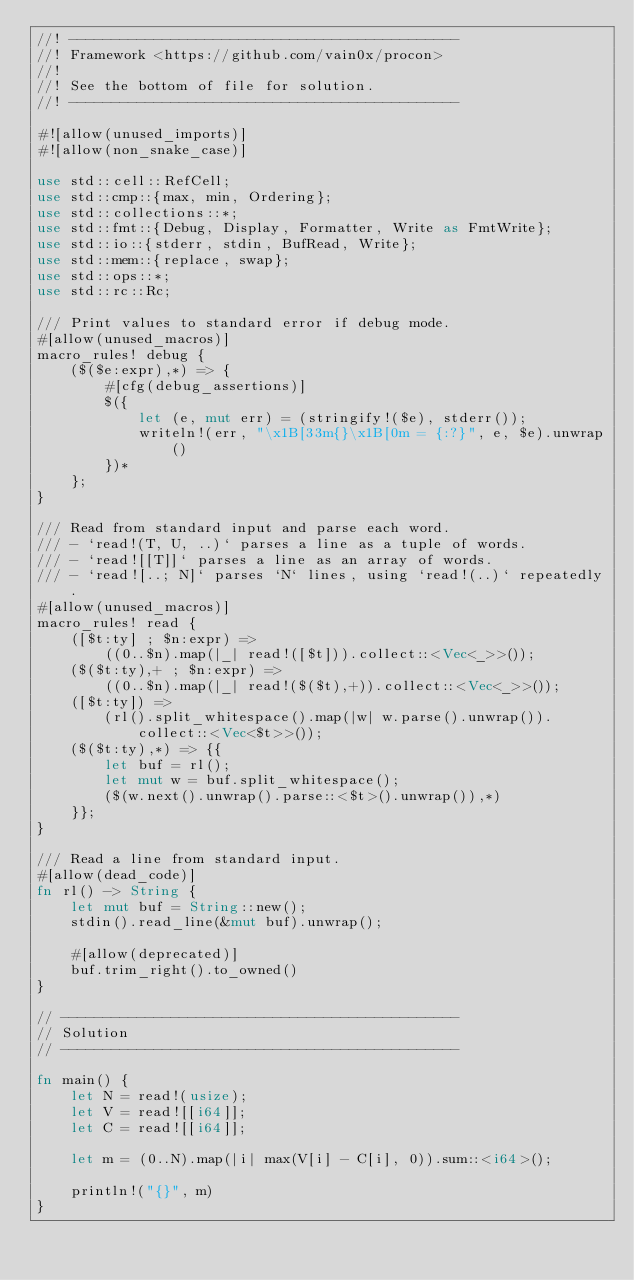Convert code to text. <code><loc_0><loc_0><loc_500><loc_500><_Rust_>//! ----------------------------------------------
//! Framework <https://github.com/vain0x/procon>
//!
//! See the bottom of file for solution.
//! ----------------------------------------------

#![allow(unused_imports)]
#![allow(non_snake_case)]

use std::cell::RefCell;
use std::cmp::{max, min, Ordering};
use std::collections::*;
use std::fmt::{Debug, Display, Formatter, Write as FmtWrite};
use std::io::{stderr, stdin, BufRead, Write};
use std::mem::{replace, swap};
use std::ops::*;
use std::rc::Rc;

/// Print values to standard error if debug mode.
#[allow(unused_macros)]
macro_rules! debug {
    ($($e:expr),*) => {
        #[cfg(debug_assertions)]
        $({
            let (e, mut err) = (stringify!($e), stderr());
            writeln!(err, "\x1B[33m{}\x1B[0m = {:?}", e, $e).unwrap()
        })*
    };
}

/// Read from standard input and parse each word.
/// - `read!(T, U, ..)` parses a line as a tuple of words.
/// - `read![[T]]` parses a line as an array of words.
/// - `read![..; N]` parses `N` lines, using `read!(..)` repeatedly.
#[allow(unused_macros)]
macro_rules! read {
    ([$t:ty] ; $n:expr) =>
        ((0..$n).map(|_| read!([$t])).collect::<Vec<_>>());
    ($($t:ty),+ ; $n:expr) =>
        ((0..$n).map(|_| read!($($t),+)).collect::<Vec<_>>());
    ([$t:ty]) =>
        (rl().split_whitespace().map(|w| w.parse().unwrap()).collect::<Vec<$t>>());
    ($($t:ty),*) => {{
        let buf = rl();
        let mut w = buf.split_whitespace();
        ($(w.next().unwrap().parse::<$t>().unwrap()),*)
    }};
}

/// Read a line from standard input.
#[allow(dead_code)]
fn rl() -> String {
    let mut buf = String::new();
    stdin().read_line(&mut buf).unwrap();

    #[allow(deprecated)]
    buf.trim_right().to_owned()
}

// -----------------------------------------------
// Solution
// -----------------------------------------------

fn main() {
    let N = read!(usize);
    let V = read![[i64]];
    let C = read![[i64]];

    let m = (0..N).map(|i| max(V[i] - C[i], 0)).sum::<i64>();

    println!("{}", m)
}
</code> 